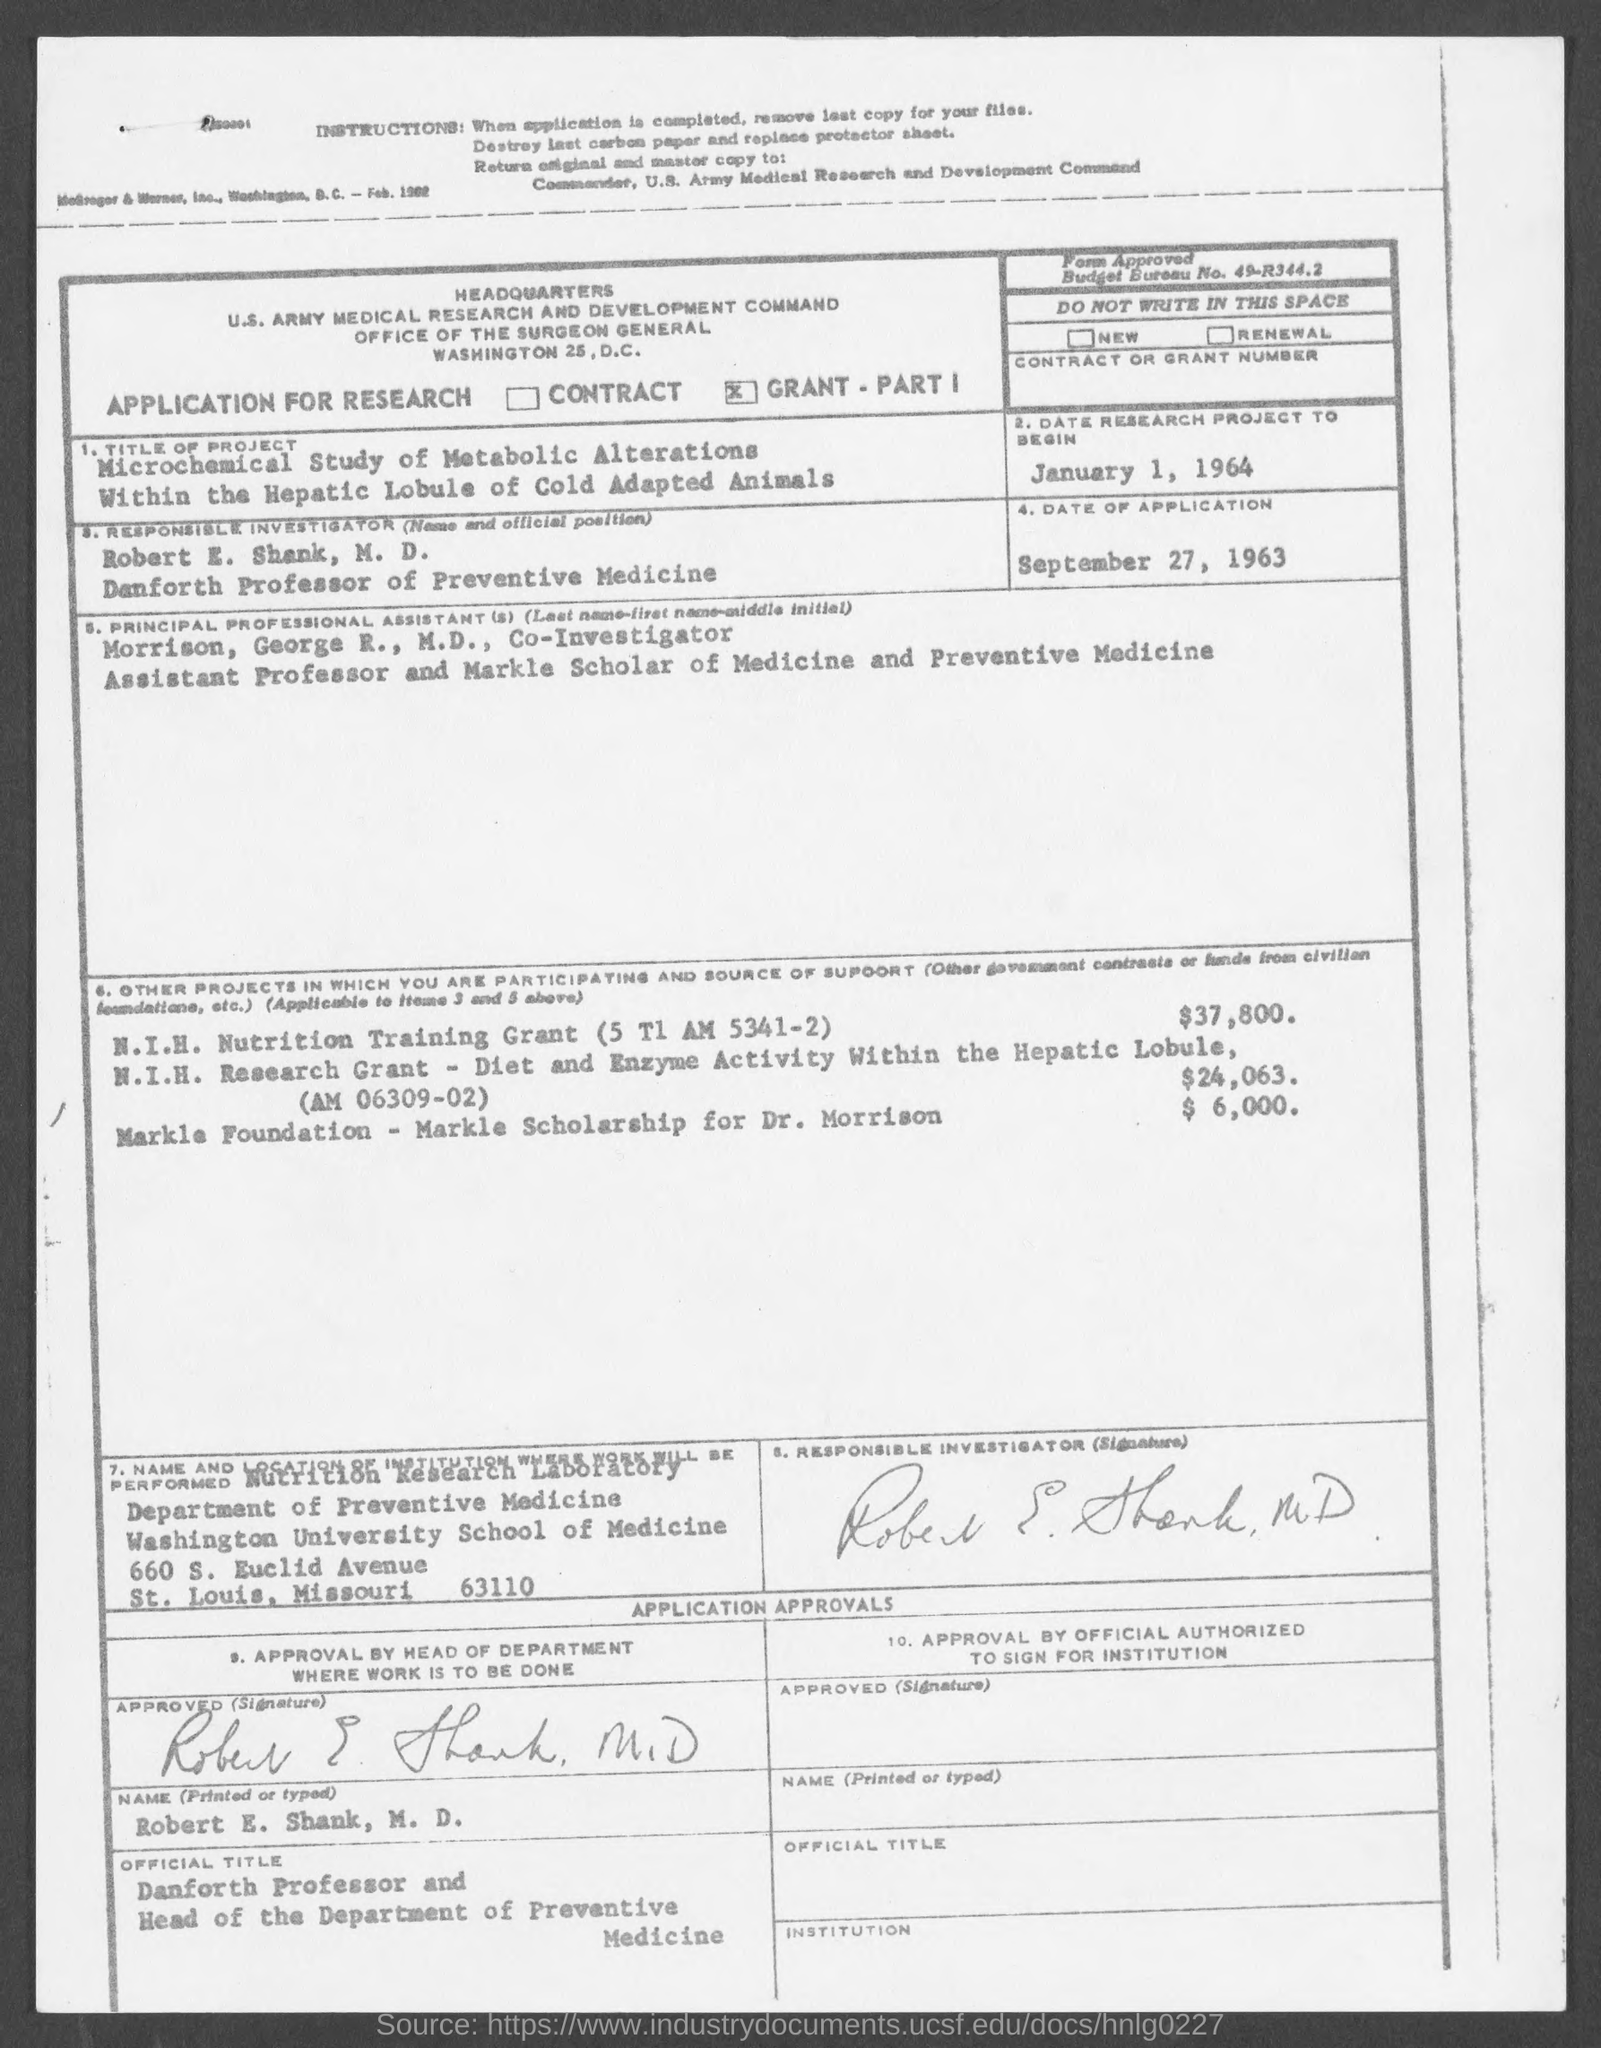What is the date of research project to begin as mentioned in the given page ?
Your answer should be very brief. January 1 , 1964. What is the title of project mentioned in the given page ?
Your answer should be very brief. Microchemical Study of Metabolic Alterations Within the Hepatic Lobule of Cold Adapted Animals. Who is the responsible investigator mentioned in the given page ?
Offer a very short reply. Robert E. Shank. What is the designation of robert e. shank ?
Your response must be concise. Danforth Professor and Head of the Department of Preventive Medicine. Who is the principal professional assistants mentioned in the given page ?
Provide a succinct answer. Morrison, George R., M.D., Co-Investigator Assistant Professor and Markle Scholar of Medicine and Preventive Medicine. 